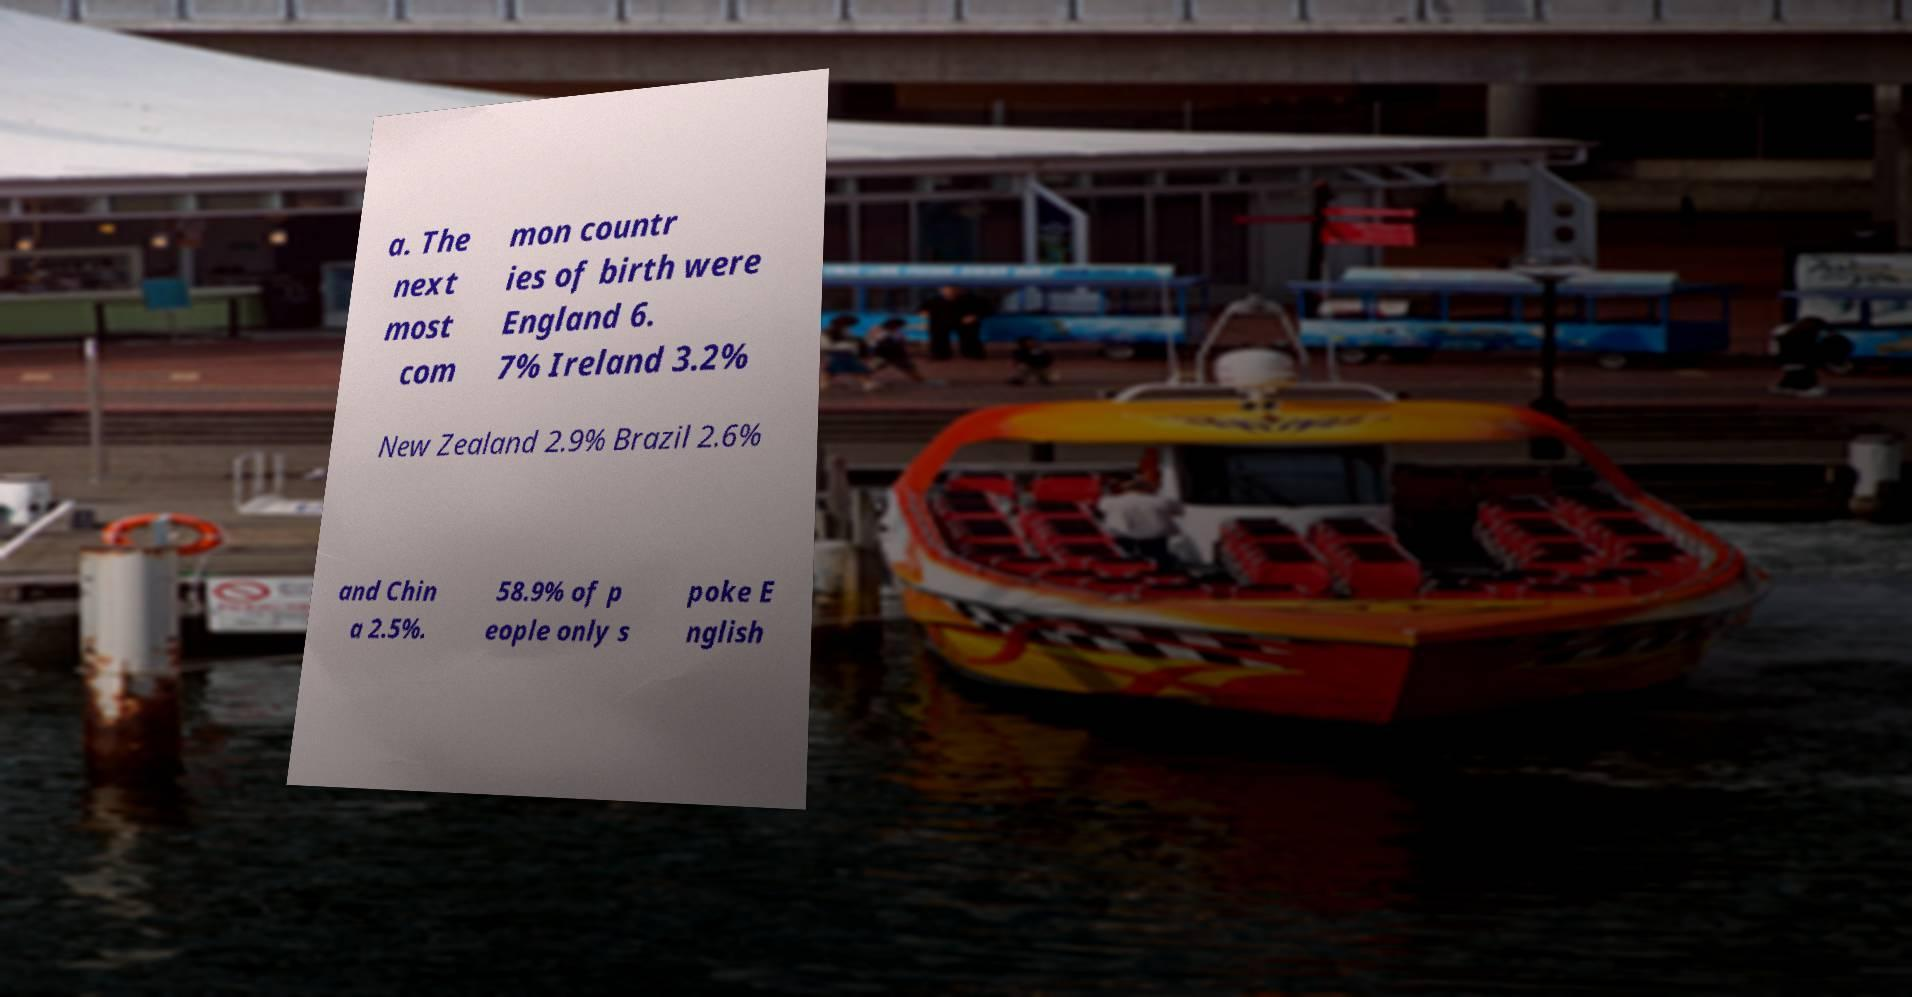There's text embedded in this image that I need extracted. Can you transcribe it verbatim? a. The next most com mon countr ies of birth were England 6. 7% Ireland 3.2% New Zealand 2.9% Brazil 2.6% and Chin a 2.5%. 58.9% of p eople only s poke E nglish 